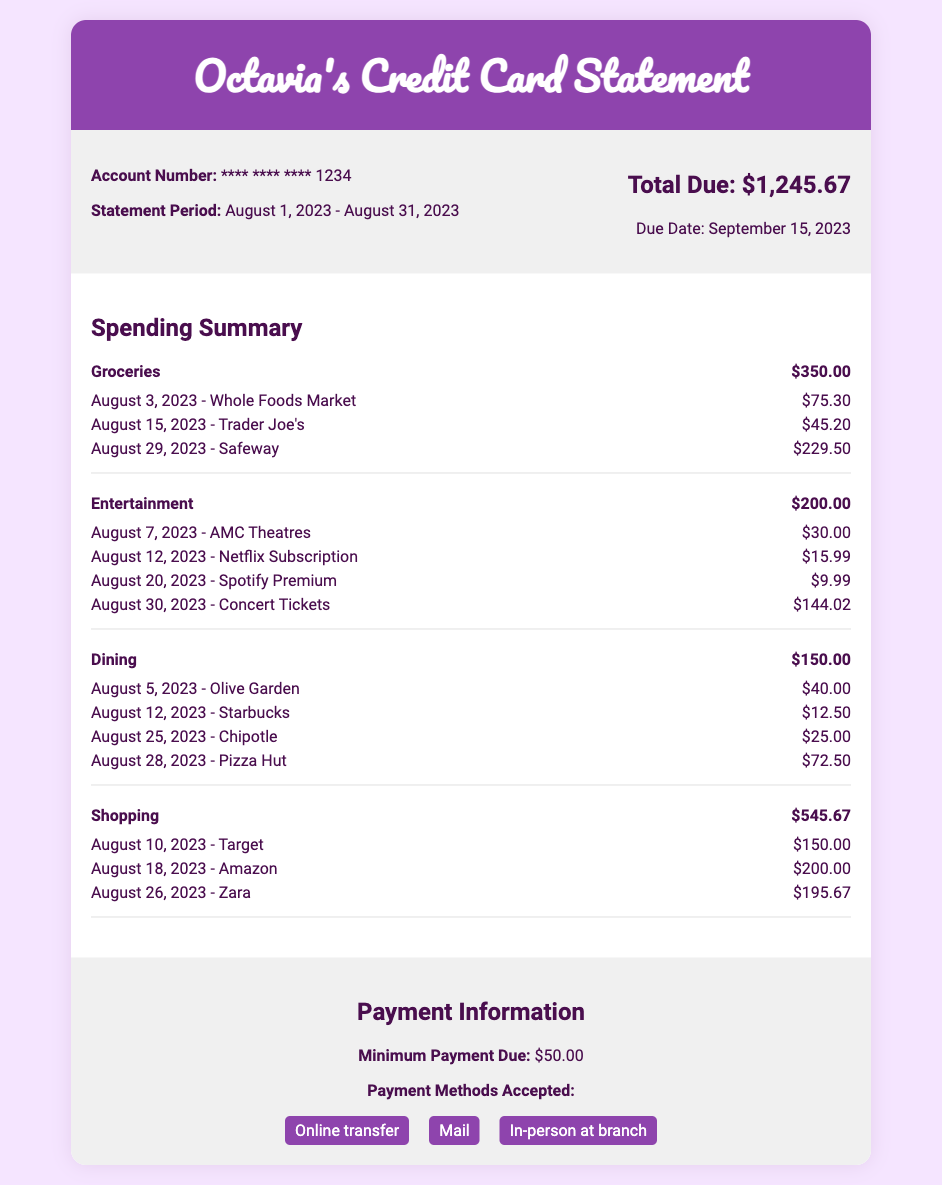What is the total due amount? The total due amount is stated at the top of the document, which is $1,245.67.
Answer: $1,245.67 What is the due date for the payment? The due date is mentioned in the statement information section, which is September 15, 2023.
Answer: September 15, 2023 How much was spent on groceries? The total spending on groceries is detailed in the spending summary, amounting to $350.00.
Answer: $350.00 What is the minimum payment due? The minimum payment due is specified in the payment information section, which is $50.00.
Answer: $50.00 Which month does this statement cover? The statement period is explicitly stated as August 1, 2023 - August 31, 2023.
Answer: August 1, 2023 - August 31, 2023 How much was spent on entertainment? The total for entertainment spending is indicated in the spending summary, which is $200.00.
Answer: $200.00 What was the largest category of spending? By looking at the total spending in each category, Shopping at $545.67 is the largest.
Answer: Shopping How many transactions are listed under Dining? The dining category contains four transactions as outlined in the spending summary.
Answer: 4 What is one of the accepted payment methods? The document lists several accepted payment methods, one of which is Online transfer.
Answer: Online transfer 